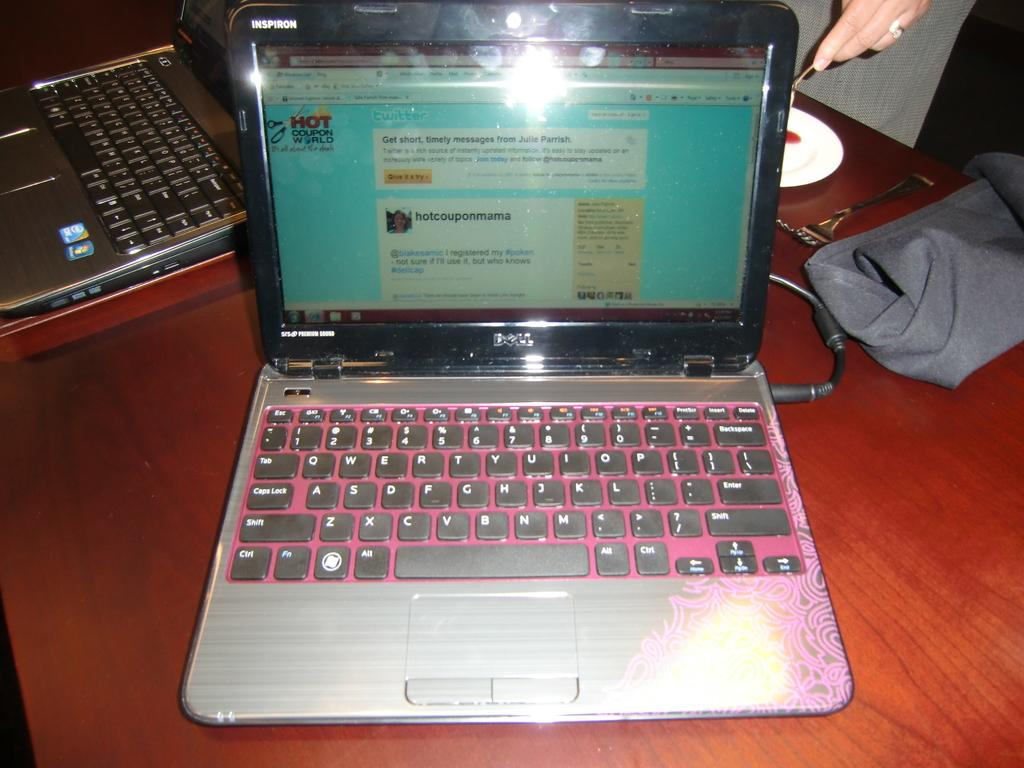Provide a one-sentence caption for the provided image. An old dell laptop sitting on top of a wood table. 